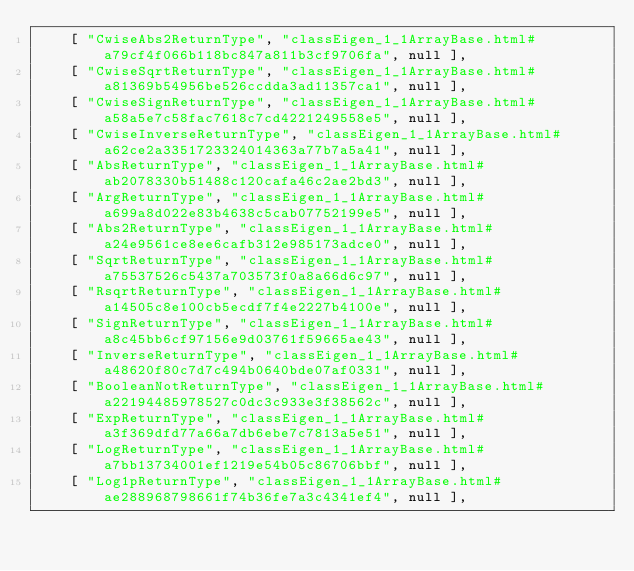<code> <loc_0><loc_0><loc_500><loc_500><_JavaScript_>    [ "CwiseAbs2ReturnType", "classEigen_1_1ArrayBase.html#a79cf4f066b118bc847a811b3cf9706fa", null ],
    [ "CwiseSqrtReturnType", "classEigen_1_1ArrayBase.html#a81369b54956be526ccdda3ad11357ca1", null ],
    [ "CwiseSignReturnType", "classEigen_1_1ArrayBase.html#a58a5e7c58fac7618c7cd4221249558e5", null ],
    [ "CwiseInverseReturnType", "classEigen_1_1ArrayBase.html#a62ce2a3351723324014363a77b7a5a41", null ],
    [ "AbsReturnType", "classEigen_1_1ArrayBase.html#ab2078330b51488c120cafa46c2ae2bd3", null ],
    [ "ArgReturnType", "classEigen_1_1ArrayBase.html#a699a8d022e83b4638c5cab07752199e5", null ],
    [ "Abs2ReturnType", "classEigen_1_1ArrayBase.html#a24e9561ce8ee6cafb312e985173adce0", null ],
    [ "SqrtReturnType", "classEigen_1_1ArrayBase.html#a75537526c5437a703573f0a8a66d6c97", null ],
    [ "RsqrtReturnType", "classEigen_1_1ArrayBase.html#a14505c8e100cb5ecdf7f4e2227b4100e", null ],
    [ "SignReturnType", "classEigen_1_1ArrayBase.html#a8c45bb6cf97156e9d03761f59665ae43", null ],
    [ "InverseReturnType", "classEigen_1_1ArrayBase.html#a48620f80c7d7c494b0640bde07af0331", null ],
    [ "BooleanNotReturnType", "classEigen_1_1ArrayBase.html#a22194485978527c0dc3c933e3f38562c", null ],
    [ "ExpReturnType", "classEigen_1_1ArrayBase.html#a3f369dfd77a66a7db6ebe7c7813a5e51", null ],
    [ "LogReturnType", "classEigen_1_1ArrayBase.html#a7bb13734001ef1219e54b05c86706bbf", null ],
    [ "Log1pReturnType", "classEigen_1_1ArrayBase.html#ae288968798661f74b36fe7a3c4341ef4", null ],</code> 